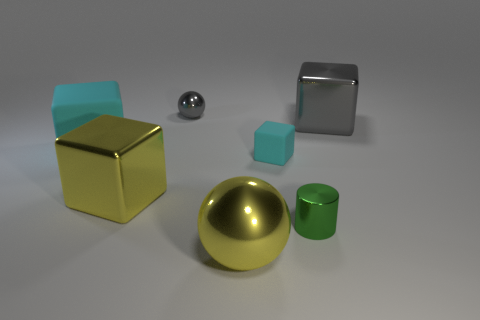There is another rubber block that is the same color as the big matte block; what size is it?
Your answer should be very brief. Small. How many objects have the same color as the tiny sphere?
Offer a terse response. 1. There is a big shiny ball; does it have the same color as the metallic cube that is to the left of the large gray shiny cube?
Provide a short and direct response. Yes. There is a ball that is in front of the large shiny block on the right side of the big yellow cube; what number of green things are behind it?
Offer a terse response. 1. There is a tiny green cylinder; are there any things on the left side of it?
Your answer should be very brief. Yes. Is there anything else that is the same color as the small metal ball?
Make the answer very short. Yes. How many cubes are either small red objects or tiny metallic things?
Your response must be concise. 0. How many objects are to the right of the tiny block and in front of the big matte object?
Provide a succinct answer. 1. Is the number of cyan cubes to the right of the big cyan cube the same as the number of spheres on the right side of the small shiny cylinder?
Provide a short and direct response. No. Does the large matte object that is on the left side of the large gray thing have the same shape as the large gray metallic object?
Keep it short and to the point. Yes. 